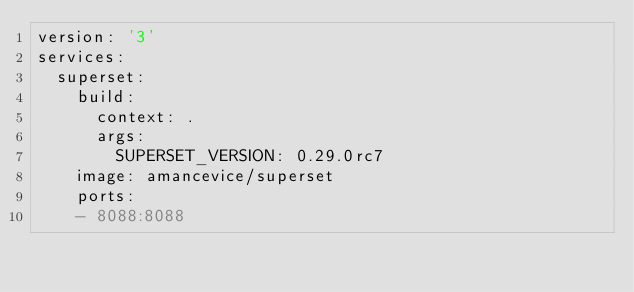<code> <loc_0><loc_0><loc_500><loc_500><_YAML_>version: '3'
services:
  superset:
    build:
      context: .
      args:
        SUPERSET_VERSION: 0.29.0rc7
    image: amancevice/superset
    ports:
    - 8088:8088
</code> 